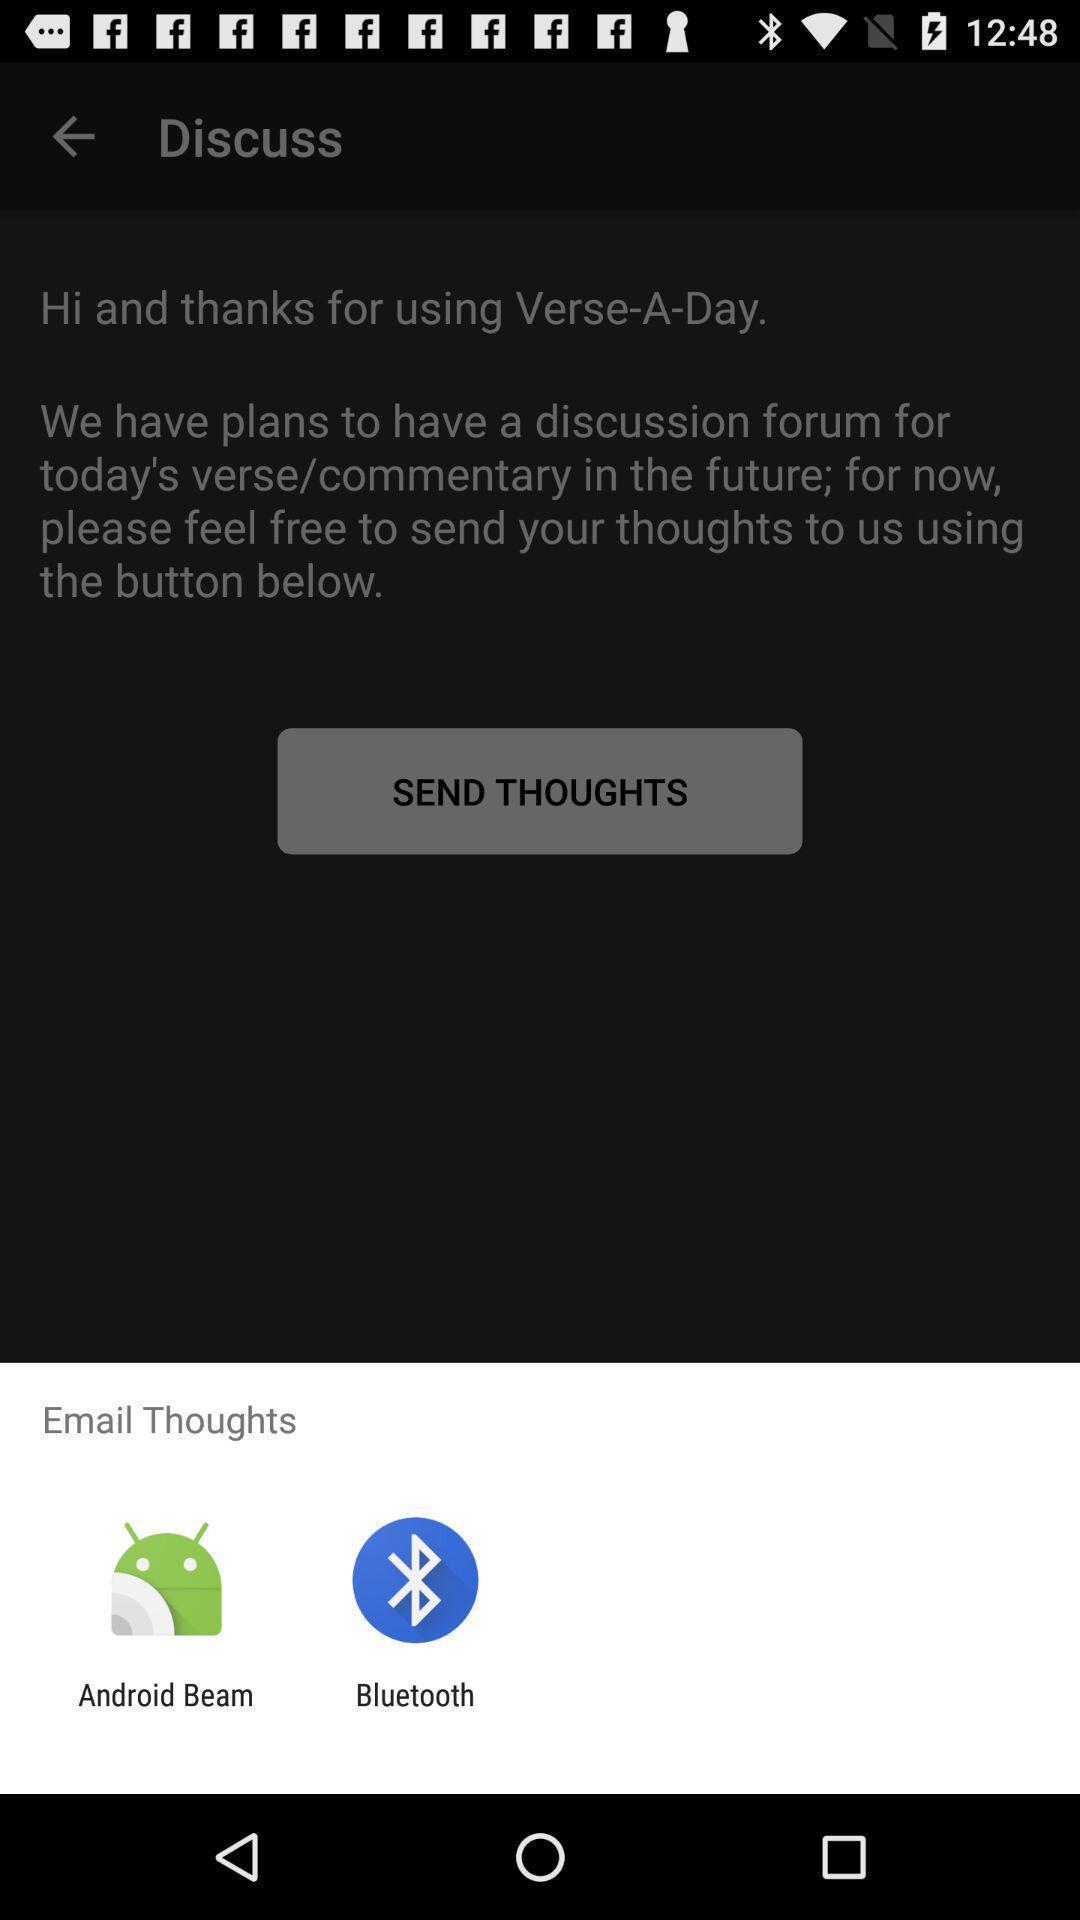What details can you identify in this image? Pop-up to share via different apps. 